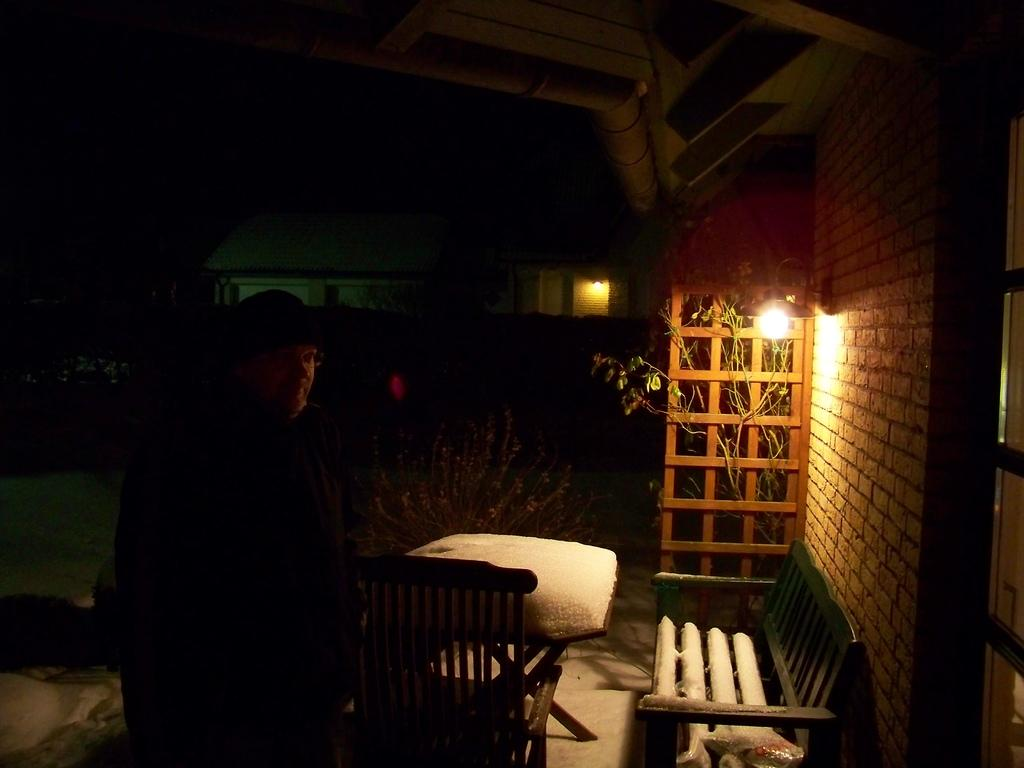What is located in the foreground of the image? In the foreground of the image, there is a man, a chair, a table, a bench, a wall, a light, and plants. Can you describe the man in the image? The man is standing in the foreground of the image. What type of furniture is present in the foreground? There is a chair and a table in the foreground of the image. What is the condition of the background in the image? The background of the image is dark. What can be seen in the background of the image? There is a building in the background of the image. Where is the zoo located in the image? There is no zoo present in the image. What type of servant is attending to the man in the image? There is no servant present in the image. Can you point out the map in the image? There is no map present in the image. 